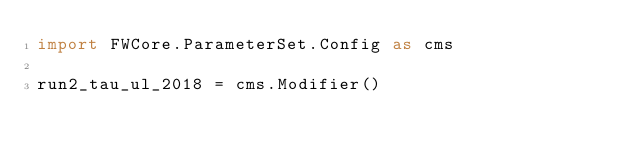Convert code to text. <code><loc_0><loc_0><loc_500><loc_500><_Python_>import FWCore.ParameterSet.Config as cms

run2_tau_ul_2018 = cms.Modifier()
</code> 